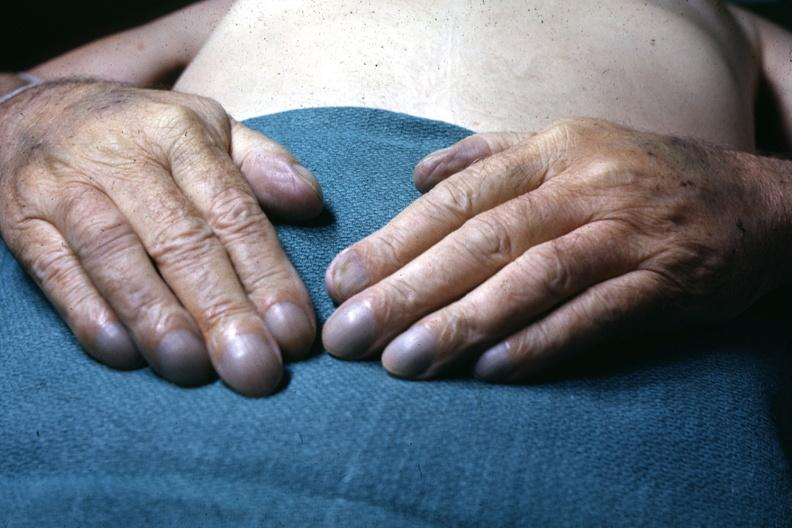s hand present?
Answer the question using a single word or phrase. Yes 